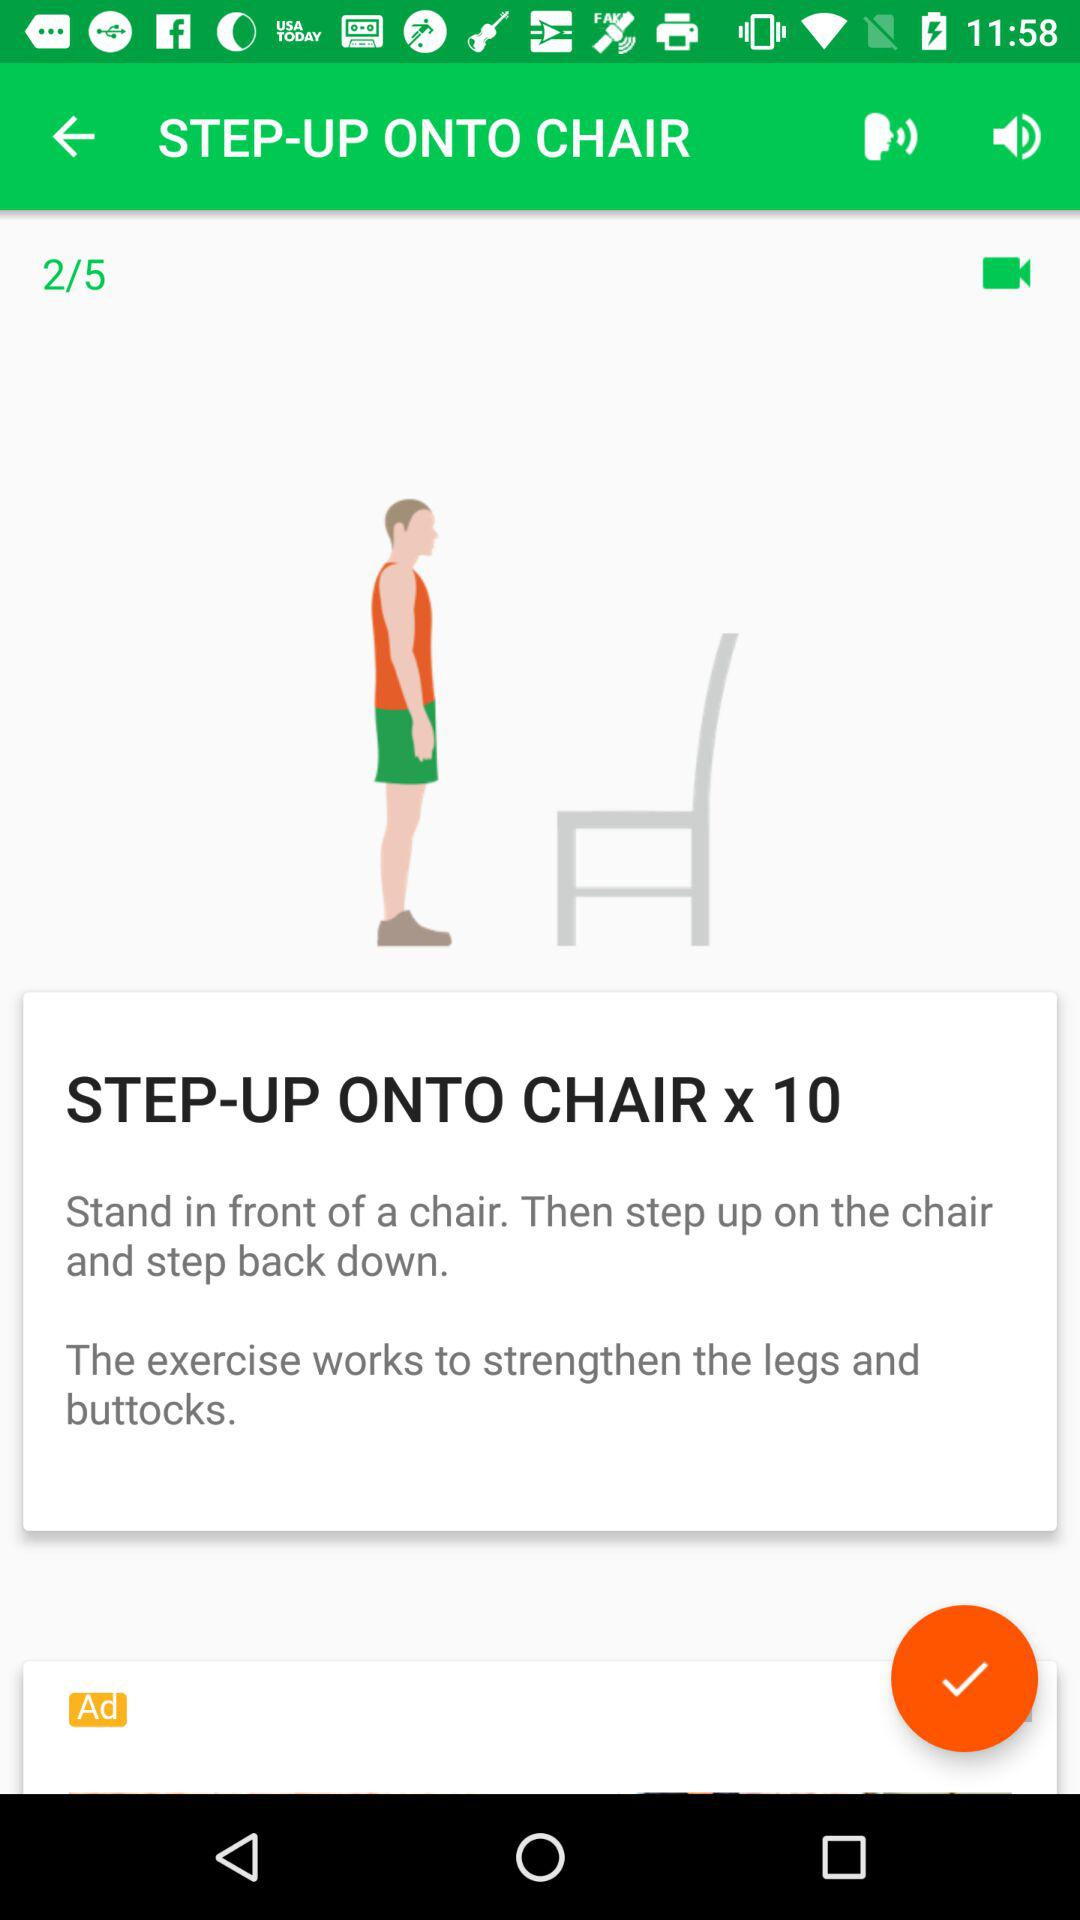How many steps are there in the exercise?
Answer the question using a single word or phrase. 10 